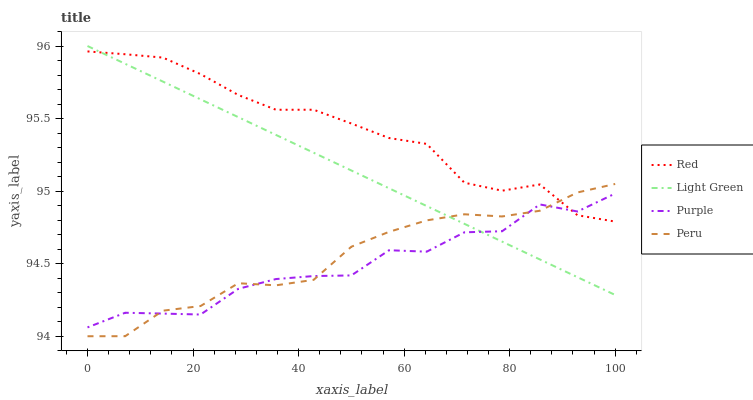Does Purple have the minimum area under the curve?
Answer yes or no. Yes. Does Red have the maximum area under the curve?
Answer yes or no. Yes. Does Peru have the minimum area under the curve?
Answer yes or no. No. Does Peru have the maximum area under the curve?
Answer yes or no. No. Is Light Green the smoothest?
Answer yes or no. Yes. Is Purple the roughest?
Answer yes or no. Yes. Is Peru the smoothest?
Answer yes or no. No. Is Peru the roughest?
Answer yes or no. No. Does Peru have the lowest value?
Answer yes or no. Yes. Does Light Green have the lowest value?
Answer yes or no. No. Does Light Green have the highest value?
Answer yes or no. Yes. Does Peru have the highest value?
Answer yes or no. No. Does Peru intersect Red?
Answer yes or no. Yes. Is Peru less than Red?
Answer yes or no. No. Is Peru greater than Red?
Answer yes or no. No. 